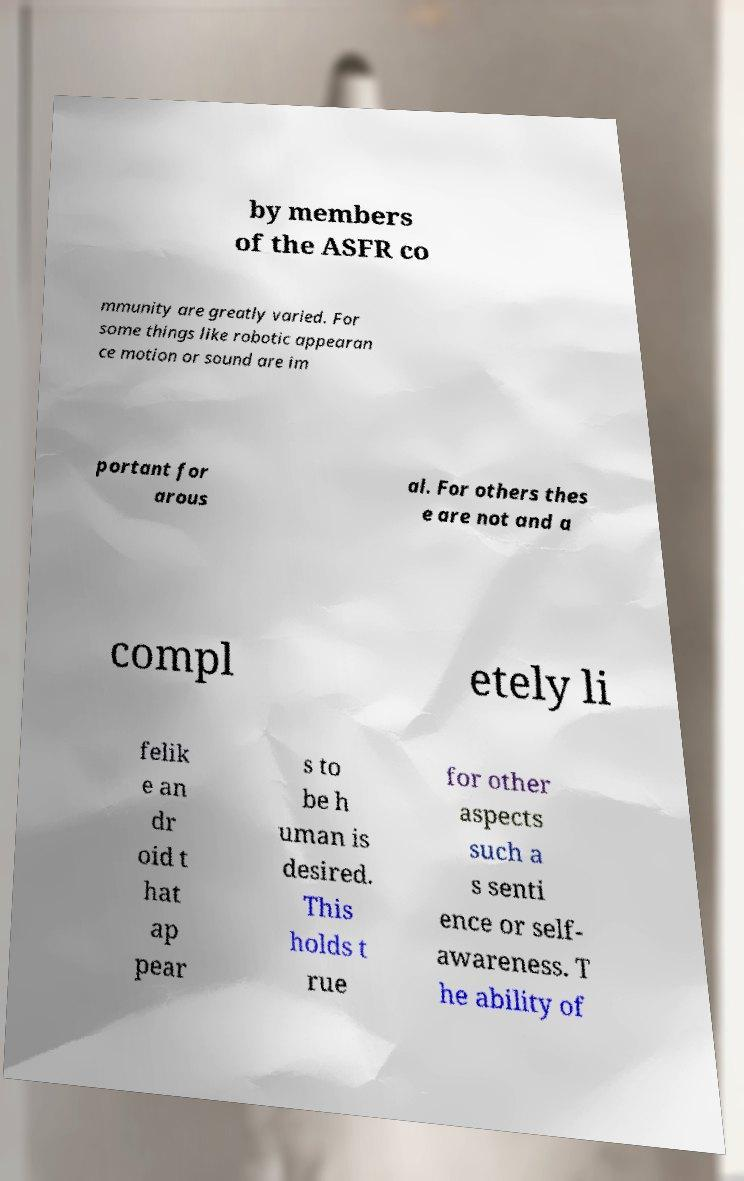For documentation purposes, I need the text within this image transcribed. Could you provide that? by members of the ASFR co mmunity are greatly varied. For some things like robotic appearan ce motion or sound are im portant for arous al. For others thes e are not and a compl etely li felik e an dr oid t hat ap pear s to be h uman is desired. This holds t rue for other aspects such a s senti ence or self- awareness. T he ability of 